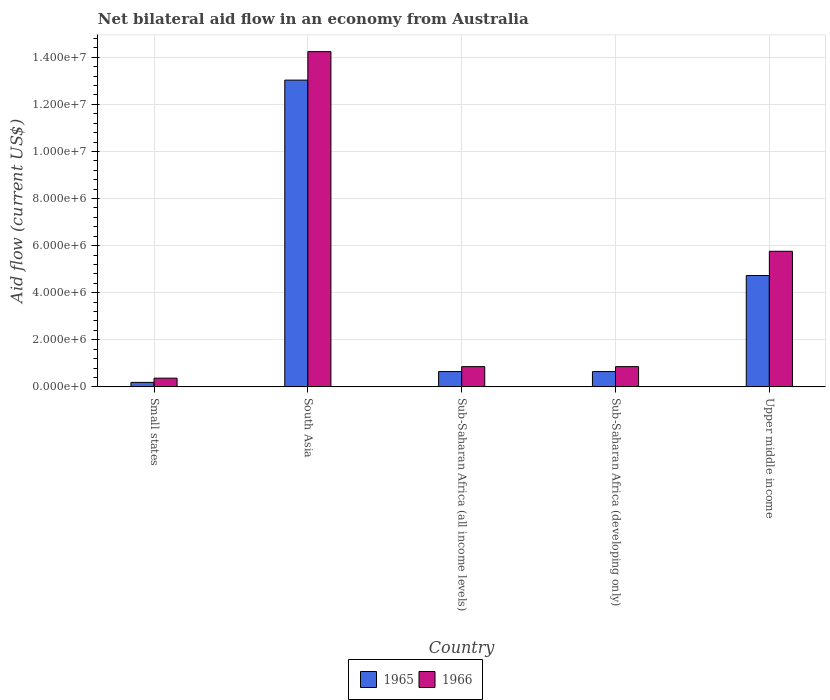How many different coloured bars are there?
Offer a terse response. 2. How many groups of bars are there?
Ensure brevity in your answer.  5. How many bars are there on the 5th tick from the left?
Your answer should be very brief. 2. How many bars are there on the 4th tick from the right?
Provide a succinct answer. 2. In how many cases, is the number of bars for a given country not equal to the number of legend labels?
Provide a succinct answer. 0. What is the net bilateral aid flow in 1965 in Small states?
Your answer should be very brief. 1.90e+05. Across all countries, what is the maximum net bilateral aid flow in 1965?
Provide a short and direct response. 1.30e+07. In which country was the net bilateral aid flow in 1965 minimum?
Offer a terse response. Small states. What is the total net bilateral aid flow in 1966 in the graph?
Ensure brevity in your answer.  2.21e+07. What is the difference between the net bilateral aid flow in 1966 in South Asia and that in Sub-Saharan Africa (all income levels)?
Provide a succinct answer. 1.34e+07. What is the difference between the net bilateral aid flow in 1966 in Upper middle income and the net bilateral aid flow in 1965 in Small states?
Offer a terse response. 5.57e+06. What is the average net bilateral aid flow in 1966 per country?
Keep it short and to the point. 4.42e+06. What is the difference between the net bilateral aid flow of/in 1965 and net bilateral aid flow of/in 1966 in South Asia?
Offer a very short reply. -1.21e+06. In how many countries, is the net bilateral aid flow in 1966 greater than 2000000 US$?
Make the answer very short. 2. What is the ratio of the net bilateral aid flow in 1966 in Small states to that in Sub-Saharan Africa (developing only)?
Provide a succinct answer. 0.43. Is the net bilateral aid flow in 1966 in Sub-Saharan Africa (developing only) less than that in Upper middle income?
Offer a very short reply. Yes. Is the difference between the net bilateral aid flow in 1965 in Sub-Saharan Africa (all income levels) and Upper middle income greater than the difference between the net bilateral aid flow in 1966 in Sub-Saharan Africa (all income levels) and Upper middle income?
Offer a terse response. Yes. What is the difference between the highest and the second highest net bilateral aid flow in 1966?
Your answer should be compact. 8.48e+06. What is the difference between the highest and the lowest net bilateral aid flow in 1966?
Your answer should be compact. 1.39e+07. In how many countries, is the net bilateral aid flow in 1966 greater than the average net bilateral aid flow in 1966 taken over all countries?
Your answer should be very brief. 2. Is the sum of the net bilateral aid flow in 1965 in South Asia and Upper middle income greater than the maximum net bilateral aid flow in 1966 across all countries?
Your response must be concise. Yes. What does the 1st bar from the left in Sub-Saharan Africa (developing only) represents?
Provide a short and direct response. 1965. What does the 1st bar from the right in Upper middle income represents?
Offer a terse response. 1966. Are all the bars in the graph horizontal?
Give a very brief answer. No. How many countries are there in the graph?
Your response must be concise. 5. What is the difference between two consecutive major ticks on the Y-axis?
Offer a terse response. 2.00e+06. Does the graph contain any zero values?
Ensure brevity in your answer.  No. Where does the legend appear in the graph?
Ensure brevity in your answer.  Bottom center. How many legend labels are there?
Ensure brevity in your answer.  2. How are the legend labels stacked?
Provide a short and direct response. Horizontal. What is the title of the graph?
Make the answer very short. Net bilateral aid flow in an economy from Australia. Does "1993" appear as one of the legend labels in the graph?
Ensure brevity in your answer.  No. What is the label or title of the X-axis?
Ensure brevity in your answer.  Country. What is the Aid flow (current US$) in 1965 in South Asia?
Make the answer very short. 1.30e+07. What is the Aid flow (current US$) in 1966 in South Asia?
Make the answer very short. 1.42e+07. What is the Aid flow (current US$) of 1965 in Sub-Saharan Africa (all income levels)?
Offer a terse response. 6.50e+05. What is the Aid flow (current US$) in 1966 in Sub-Saharan Africa (all income levels)?
Give a very brief answer. 8.60e+05. What is the Aid flow (current US$) in 1965 in Sub-Saharan Africa (developing only)?
Make the answer very short. 6.50e+05. What is the Aid flow (current US$) of 1966 in Sub-Saharan Africa (developing only)?
Offer a very short reply. 8.60e+05. What is the Aid flow (current US$) of 1965 in Upper middle income?
Your answer should be very brief. 4.73e+06. What is the Aid flow (current US$) in 1966 in Upper middle income?
Offer a terse response. 5.76e+06. Across all countries, what is the maximum Aid flow (current US$) of 1965?
Give a very brief answer. 1.30e+07. Across all countries, what is the maximum Aid flow (current US$) of 1966?
Make the answer very short. 1.42e+07. Across all countries, what is the minimum Aid flow (current US$) of 1965?
Offer a very short reply. 1.90e+05. Across all countries, what is the minimum Aid flow (current US$) of 1966?
Provide a succinct answer. 3.70e+05. What is the total Aid flow (current US$) of 1965 in the graph?
Your answer should be very brief. 1.92e+07. What is the total Aid flow (current US$) of 1966 in the graph?
Provide a short and direct response. 2.21e+07. What is the difference between the Aid flow (current US$) in 1965 in Small states and that in South Asia?
Provide a short and direct response. -1.28e+07. What is the difference between the Aid flow (current US$) of 1966 in Small states and that in South Asia?
Provide a short and direct response. -1.39e+07. What is the difference between the Aid flow (current US$) in 1965 in Small states and that in Sub-Saharan Africa (all income levels)?
Your response must be concise. -4.60e+05. What is the difference between the Aid flow (current US$) of 1966 in Small states and that in Sub-Saharan Africa (all income levels)?
Your answer should be compact. -4.90e+05. What is the difference between the Aid flow (current US$) of 1965 in Small states and that in Sub-Saharan Africa (developing only)?
Offer a very short reply. -4.60e+05. What is the difference between the Aid flow (current US$) in 1966 in Small states and that in Sub-Saharan Africa (developing only)?
Make the answer very short. -4.90e+05. What is the difference between the Aid flow (current US$) of 1965 in Small states and that in Upper middle income?
Offer a terse response. -4.54e+06. What is the difference between the Aid flow (current US$) of 1966 in Small states and that in Upper middle income?
Your response must be concise. -5.39e+06. What is the difference between the Aid flow (current US$) of 1965 in South Asia and that in Sub-Saharan Africa (all income levels)?
Offer a terse response. 1.24e+07. What is the difference between the Aid flow (current US$) in 1966 in South Asia and that in Sub-Saharan Africa (all income levels)?
Ensure brevity in your answer.  1.34e+07. What is the difference between the Aid flow (current US$) in 1965 in South Asia and that in Sub-Saharan Africa (developing only)?
Ensure brevity in your answer.  1.24e+07. What is the difference between the Aid flow (current US$) of 1966 in South Asia and that in Sub-Saharan Africa (developing only)?
Keep it short and to the point. 1.34e+07. What is the difference between the Aid flow (current US$) of 1965 in South Asia and that in Upper middle income?
Your answer should be compact. 8.30e+06. What is the difference between the Aid flow (current US$) of 1966 in South Asia and that in Upper middle income?
Your answer should be compact. 8.48e+06. What is the difference between the Aid flow (current US$) in 1965 in Sub-Saharan Africa (all income levels) and that in Sub-Saharan Africa (developing only)?
Provide a succinct answer. 0. What is the difference between the Aid flow (current US$) in 1965 in Sub-Saharan Africa (all income levels) and that in Upper middle income?
Provide a short and direct response. -4.08e+06. What is the difference between the Aid flow (current US$) of 1966 in Sub-Saharan Africa (all income levels) and that in Upper middle income?
Provide a succinct answer. -4.90e+06. What is the difference between the Aid flow (current US$) of 1965 in Sub-Saharan Africa (developing only) and that in Upper middle income?
Offer a terse response. -4.08e+06. What is the difference between the Aid flow (current US$) in 1966 in Sub-Saharan Africa (developing only) and that in Upper middle income?
Your response must be concise. -4.90e+06. What is the difference between the Aid flow (current US$) of 1965 in Small states and the Aid flow (current US$) of 1966 in South Asia?
Your answer should be compact. -1.40e+07. What is the difference between the Aid flow (current US$) of 1965 in Small states and the Aid flow (current US$) of 1966 in Sub-Saharan Africa (all income levels)?
Offer a terse response. -6.70e+05. What is the difference between the Aid flow (current US$) of 1965 in Small states and the Aid flow (current US$) of 1966 in Sub-Saharan Africa (developing only)?
Offer a very short reply. -6.70e+05. What is the difference between the Aid flow (current US$) in 1965 in Small states and the Aid flow (current US$) in 1966 in Upper middle income?
Keep it short and to the point. -5.57e+06. What is the difference between the Aid flow (current US$) in 1965 in South Asia and the Aid flow (current US$) in 1966 in Sub-Saharan Africa (all income levels)?
Offer a very short reply. 1.22e+07. What is the difference between the Aid flow (current US$) in 1965 in South Asia and the Aid flow (current US$) in 1966 in Sub-Saharan Africa (developing only)?
Your response must be concise. 1.22e+07. What is the difference between the Aid flow (current US$) in 1965 in South Asia and the Aid flow (current US$) in 1966 in Upper middle income?
Provide a succinct answer. 7.27e+06. What is the difference between the Aid flow (current US$) in 1965 in Sub-Saharan Africa (all income levels) and the Aid flow (current US$) in 1966 in Upper middle income?
Provide a succinct answer. -5.11e+06. What is the difference between the Aid flow (current US$) of 1965 in Sub-Saharan Africa (developing only) and the Aid flow (current US$) of 1966 in Upper middle income?
Provide a short and direct response. -5.11e+06. What is the average Aid flow (current US$) in 1965 per country?
Offer a very short reply. 3.85e+06. What is the average Aid flow (current US$) in 1966 per country?
Your response must be concise. 4.42e+06. What is the difference between the Aid flow (current US$) in 1965 and Aid flow (current US$) in 1966 in Small states?
Ensure brevity in your answer.  -1.80e+05. What is the difference between the Aid flow (current US$) in 1965 and Aid flow (current US$) in 1966 in South Asia?
Your answer should be very brief. -1.21e+06. What is the difference between the Aid flow (current US$) in 1965 and Aid flow (current US$) in 1966 in Sub-Saharan Africa (developing only)?
Keep it short and to the point. -2.10e+05. What is the difference between the Aid flow (current US$) of 1965 and Aid flow (current US$) of 1966 in Upper middle income?
Provide a succinct answer. -1.03e+06. What is the ratio of the Aid flow (current US$) of 1965 in Small states to that in South Asia?
Keep it short and to the point. 0.01. What is the ratio of the Aid flow (current US$) in 1966 in Small states to that in South Asia?
Provide a succinct answer. 0.03. What is the ratio of the Aid flow (current US$) of 1965 in Small states to that in Sub-Saharan Africa (all income levels)?
Your answer should be very brief. 0.29. What is the ratio of the Aid flow (current US$) in 1966 in Small states to that in Sub-Saharan Africa (all income levels)?
Make the answer very short. 0.43. What is the ratio of the Aid flow (current US$) of 1965 in Small states to that in Sub-Saharan Africa (developing only)?
Your answer should be compact. 0.29. What is the ratio of the Aid flow (current US$) in 1966 in Small states to that in Sub-Saharan Africa (developing only)?
Ensure brevity in your answer.  0.43. What is the ratio of the Aid flow (current US$) of 1965 in Small states to that in Upper middle income?
Keep it short and to the point. 0.04. What is the ratio of the Aid flow (current US$) in 1966 in Small states to that in Upper middle income?
Your answer should be very brief. 0.06. What is the ratio of the Aid flow (current US$) of 1965 in South Asia to that in Sub-Saharan Africa (all income levels)?
Give a very brief answer. 20.05. What is the ratio of the Aid flow (current US$) in 1966 in South Asia to that in Sub-Saharan Africa (all income levels)?
Offer a terse response. 16.56. What is the ratio of the Aid flow (current US$) of 1965 in South Asia to that in Sub-Saharan Africa (developing only)?
Offer a terse response. 20.05. What is the ratio of the Aid flow (current US$) of 1966 in South Asia to that in Sub-Saharan Africa (developing only)?
Offer a terse response. 16.56. What is the ratio of the Aid flow (current US$) in 1965 in South Asia to that in Upper middle income?
Make the answer very short. 2.75. What is the ratio of the Aid flow (current US$) in 1966 in South Asia to that in Upper middle income?
Give a very brief answer. 2.47. What is the ratio of the Aid flow (current US$) of 1965 in Sub-Saharan Africa (all income levels) to that in Upper middle income?
Give a very brief answer. 0.14. What is the ratio of the Aid flow (current US$) of 1966 in Sub-Saharan Africa (all income levels) to that in Upper middle income?
Keep it short and to the point. 0.15. What is the ratio of the Aid flow (current US$) of 1965 in Sub-Saharan Africa (developing only) to that in Upper middle income?
Provide a short and direct response. 0.14. What is the ratio of the Aid flow (current US$) in 1966 in Sub-Saharan Africa (developing only) to that in Upper middle income?
Give a very brief answer. 0.15. What is the difference between the highest and the second highest Aid flow (current US$) in 1965?
Provide a succinct answer. 8.30e+06. What is the difference between the highest and the second highest Aid flow (current US$) in 1966?
Provide a short and direct response. 8.48e+06. What is the difference between the highest and the lowest Aid flow (current US$) in 1965?
Your answer should be compact. 1.28e+07. What is the difference between the highest and the lowest Aid flow (current US$) of 1966?
Your answer should be compact. 1.39e+07. 